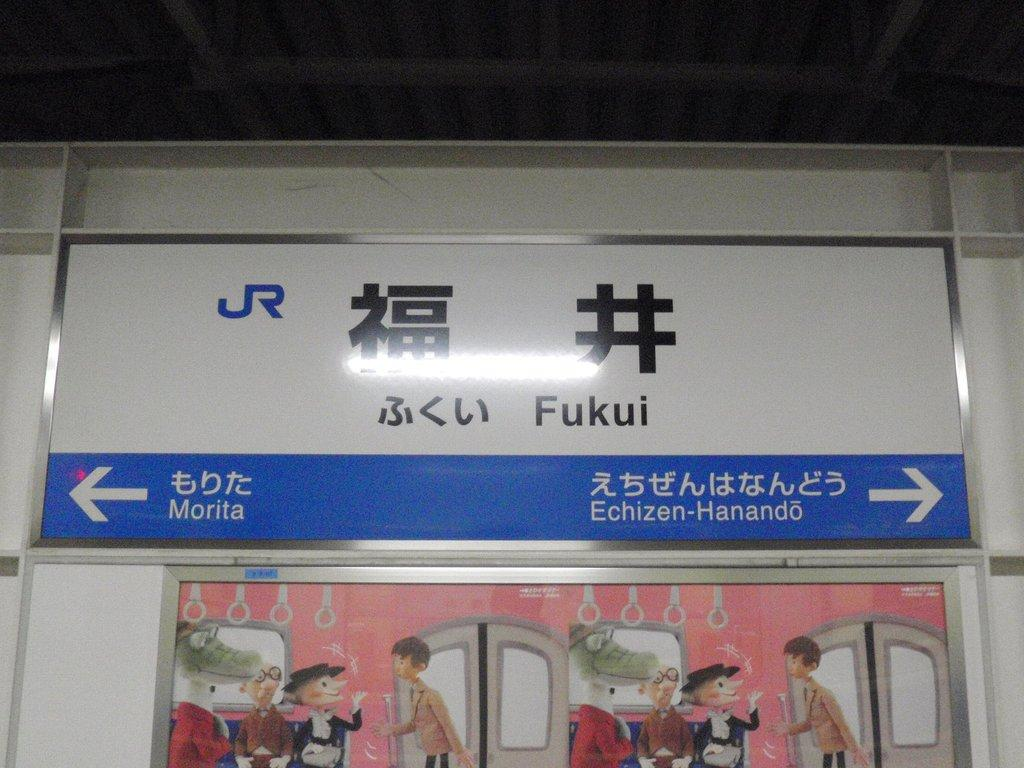What can be seen in the image? There are pictures and a white color wall in the image. What is written on the wall? The wall has "FUKUI" printed on it. What type of humor is depicted in the pictures? There is no indication of humor in the pictures, as the facts provided do not mention any humorous content. 